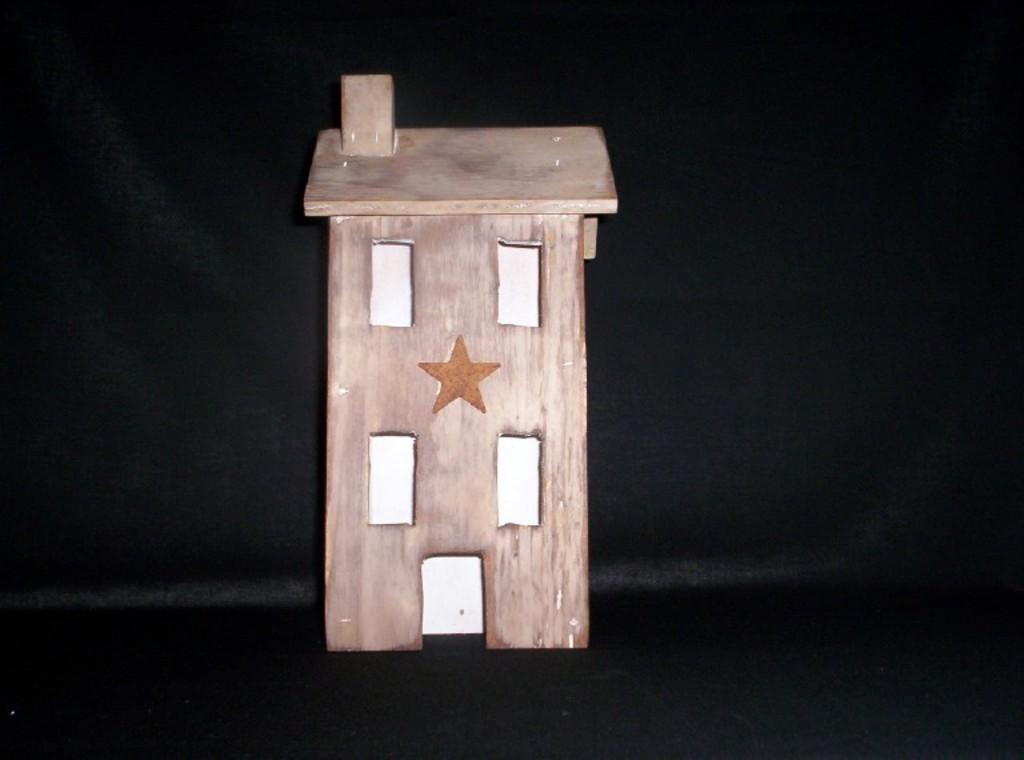What type of toy is present in the image? There is a toy house in the image. What features can be seen on the toy house? The toy house has windows and a star. On what surface is the toy house placed? The toy house is placed on a surface. What language is spoken by the toy house in the image? The toy house does not speak a language, as it is an inanimate object. 